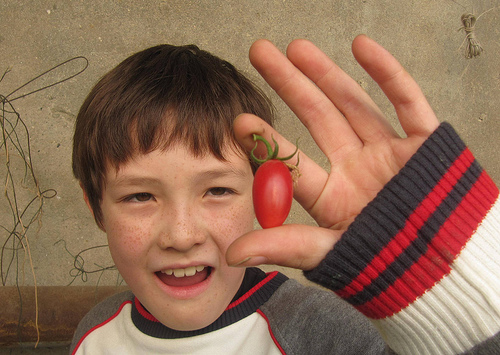<image>
Is there a tomato behind the boy? No. The tomato is not behind the boy. From this viewpoint, the tomato appears to be positioned elsewhere in the scene. Is there a tomato in front of the shirt? No. The tomato is not in front of the shirt. The spatial positioning shows a different relationship between these objects. 